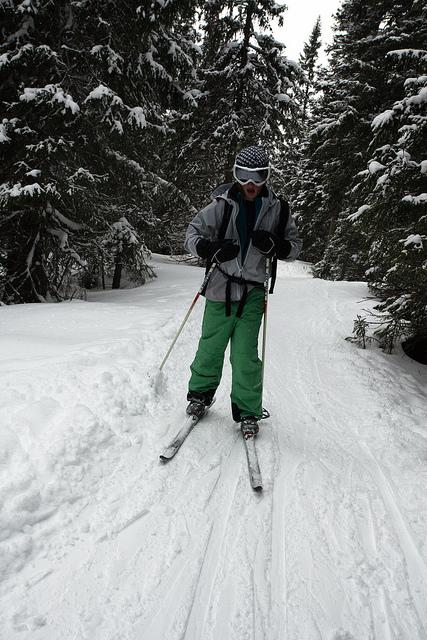What is on the trees?
Write a very short answer. Snow. Is this a ski resort?
Give a very brief answer. No. What color is the snow?
Give a very brief answer. White. 